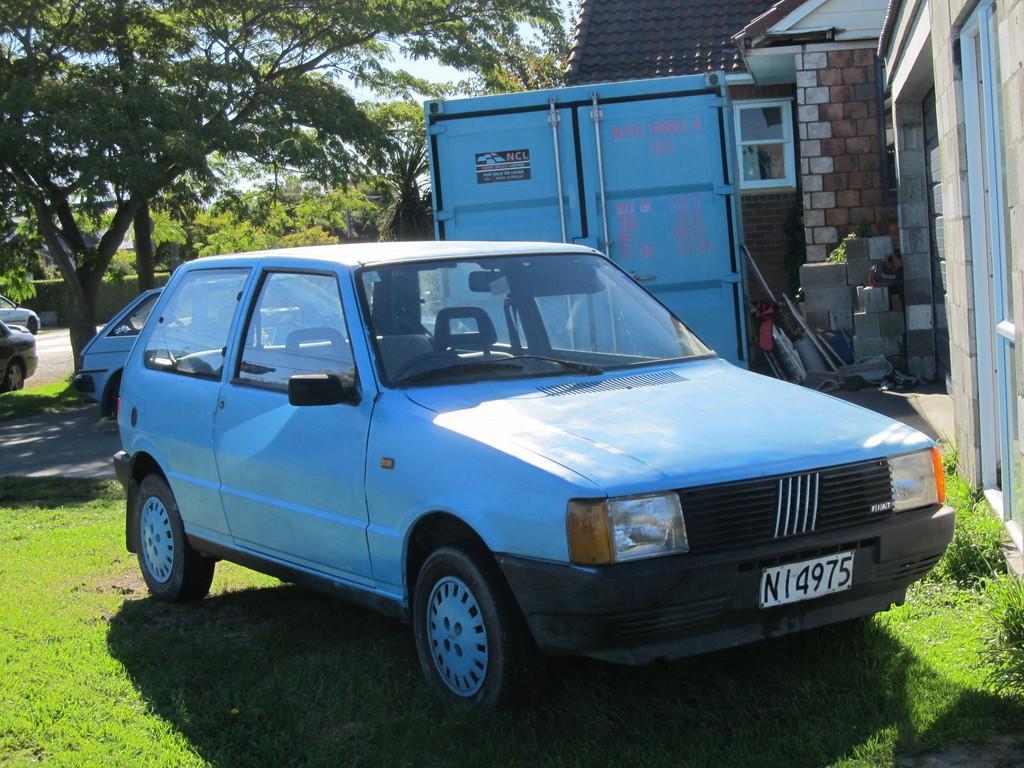Could you give a brief overview of what you see in this image? In this picture I can see vehicles, grass, plants, cardboard boxes and some other items, there is a house, there are trees, and in the background there is sky. 